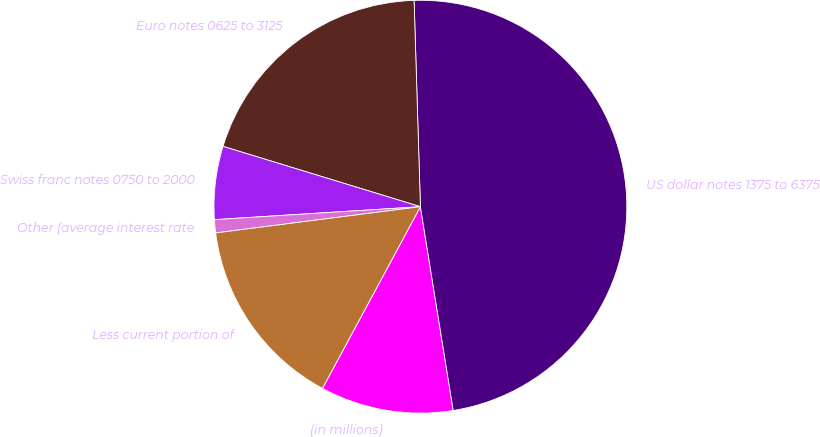<chart> <loc_0><loc_0><loc_500><loc_500><pie_chart><fcel>(in millions)<fcel>US dollar notes 1375 to 6375<fcel>Euro notes 0625 to 3125<fcel>Swiss franc notes 0750 to 2000<fcel>Other (average interest rate<fcel>Less current portion of<nl><fcel>10.41%<fcel>47.94%<fcel>19.79%<fcel>5.72%<fcel>1.03%<fcel>15.1%<nl></chart> 